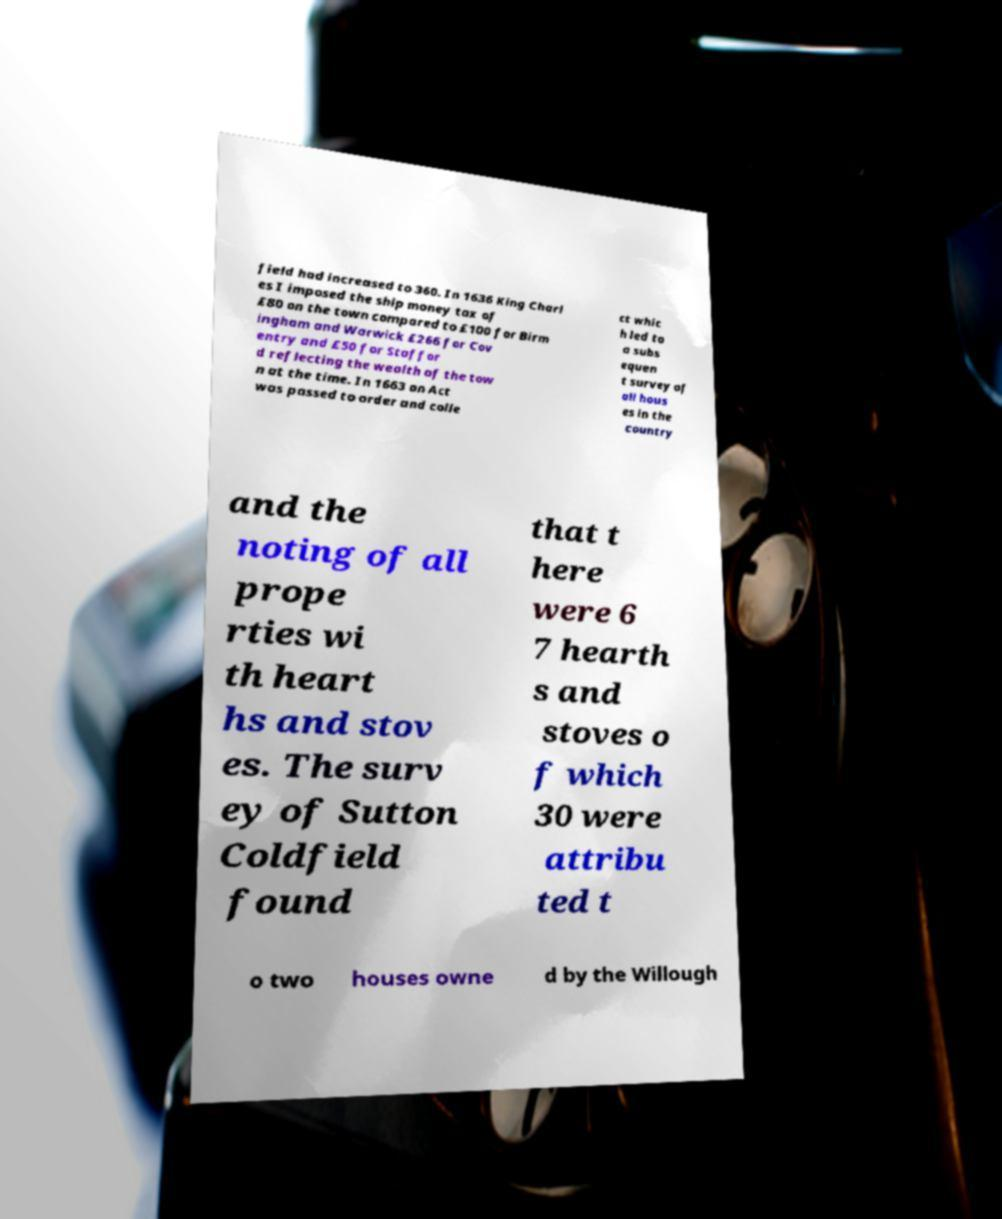For documentation purposes, I need the text within this image transcribed. Could you provide that? field had increased to 360. In 1636 King Charl es I imposed the ship money tax of £80 on the town compared to £100 for Birm ingham and Warwick £266 for Cov entry and £50 for Staffor d reflecting the wealth of the tow n at the time. In 1663 an Act was passed to order and colle ct whic h led to a subs equen t survey of all hous es in the country and the noting of all prope rties wi th heart hs and stov es. The surv ey of Sutton Coldfield found that t here were 6 7 hearth s and stoves o f which 30 were attribu ted t o two houses owne d by the Willough 